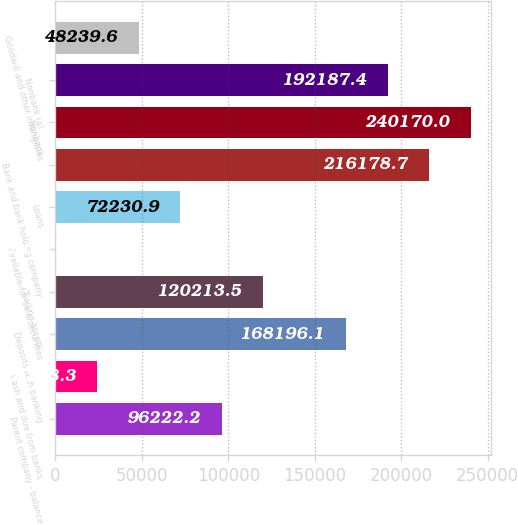Convert chart to OTSL. <chart><loc_0><loc_0><loc_500><loc_500><bar_chart><fcel>Parent company - balance<fcel>Cash and due from banks<fcel>Deposits with banking<fcel>Trading assets<fcel>Available-for-sale securities<fcel>Loans<fcel>Bank and bank holding company<fcel>Nonbank<fcel>Nonbank (a)<fcel>Goodwill and other intangibles<nl><fcel>96222.2<fcel>24248.3<fcel>168196<fcel>120214<fcel>257<fcel>72230.9<fcel>216179<fcel>240170<fcel>192187<fcel>48239.6<nl></chart> 